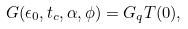Convert formula to latex. <formula><loc_0><loc_0><loc_500><loc_500>G ( \epsilon _ { 0 } , t _ { c } , \alpha , \phi ) = G _ { q } T ( 0 ) ,</formula> 